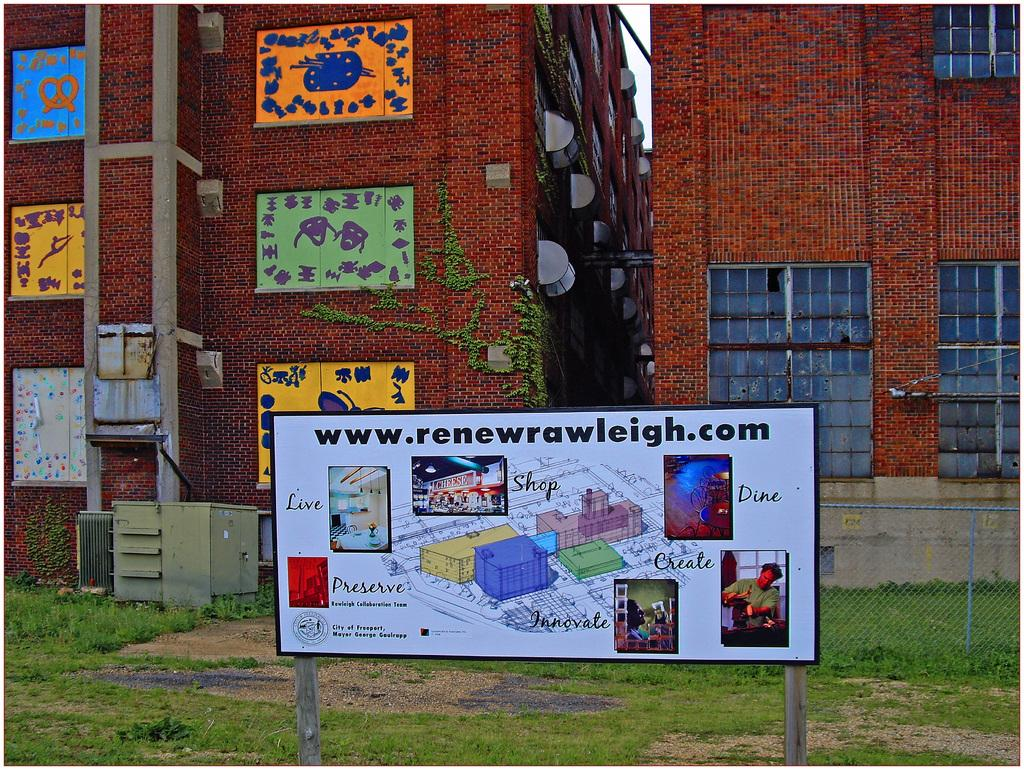<image>
Render a clear and concise summary of the photo. An sign for www.renewrawleigh.com in the city of Freeport. 